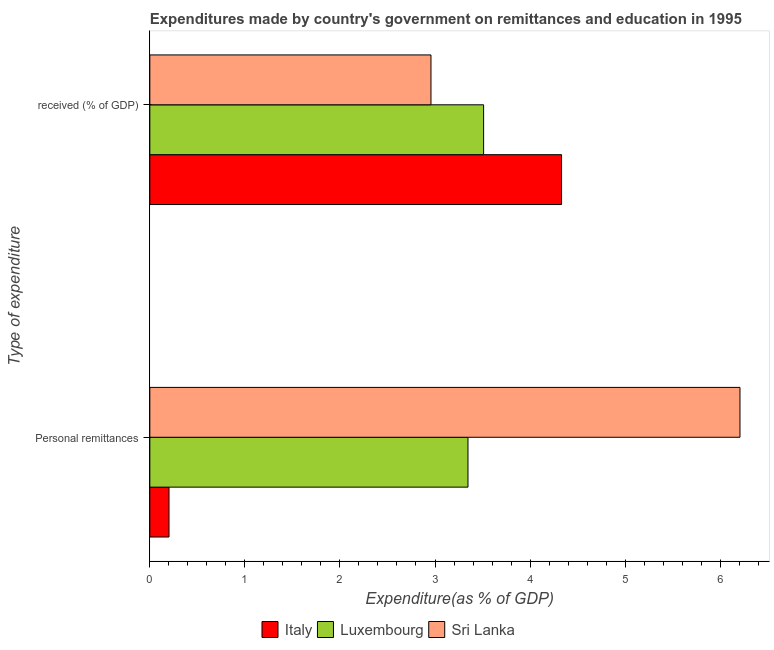How many groups of bars are there?
Keep it short and to the point. 2. Are the number of bars per tick equal to the number of legend labels?
Offer a terse response. Yes. Are the number of bars on each tick of the Y-axis equal?
Ensure brevity in your answer.  Yes. How many bars are there on the 2nd tick from the top?
Provide a short and direct response. 3. What is the label of the 1st group of bars from the top?
Keep it short and to the point.  received (% of GDP). What is the expenditure in education in Sri Lanka?
Make the answer very short. 2.96. Across all countries, what is the maximum expenditure in education?
Your answer should be very brief. 4.33. Across all countries, what is the minimum expenditure in education?
Ensure brevity in your answer.  2.96. In which country was the expenditure in education maximum?
Keep it short and to the point. Italy. In which country was the expenditure in education minimum?
Give a very brief answer. Sri Lanka. What is the total expenditure in personal remittances in the graph?
Give a very brief answer. 9.76. What is the difference between the expenditure in education in Luxembourg and that in Italy?
Provide a short and direct response. -0.82. What is the difference between the expenditure in personal remittances in Luxembourg and the expenditure in education in Italy?
Provide a short and direct response. -0.98. What is the average expenditure in education per country?
Offer a very short reply. 3.6. What is the difference between the expenditure in personal remittances and expenditure in education in Italy?
Make the answer very short. -4.13. In how many countries, is the expenditure in personal remittances greater than 3.4 %?
Keep it short and to the point. 1. What is the ratio of the expenditure in education in Sri Lanka to that in Italy?
Your answer should be very brief. 0.68. Is the expenditure in education in Italy less than that in Sri Lanka?
Keep it short and to the point. No. What does the 3rd bar from the top in  received (% of GDP) represents?
Your answer should be very brief. Italy. What does the 2nd bar from the bottom in Personal remittances represents?
Provide a succinct answer. Luxembourg. How many bars are there?
Ensure brevity in your answer.  6. Are all the bars in the graph horizontal?
Your answer should be compact. Yes. How many countries are there in the graph?
Make the answer very short. 3. What is the difference between two consecutive major ticks on the X-axis?
Your response must be concise. 1. Does the graph contain any zero values?
Give a very brief answer. No. Does the graph contain grids?
Offer a terse response. No. Where does the legend appear in the graph?
Your response must be concise. Bottom center. How are the legend labels stacked?
Ensure brevity in your answer.  Horizontal. What is the title of the graph?
Your response must be concise. Expenditures made by country's government on remittances and education in 1995. Does "Brazil" appear as one of the legend labels in the graph?
Provide a short and direct response. No. What is the label or title of the X-axis?
Offer a terse response. Expenditure(as % of GDP). What is the label or title of the Y-axis?
Ensure brevity in your answer.  Type of expenditure. What is the Expenditure(as % of GDP) of Italy in Personal remittances?
Provide a succinct answer. 0.2. What is the Expenditure(as % of GDP) in Luxembourg in Personal remittances?
Keep it short and to the point. 3.35. What is the Expenditure(as % of GDP) of Sri Lanka in Personal remittances?
Provide a succinct answer. 6.21. What is the Expenditure(as % of GDP) in Italy in  received (% of GDP)?
Your answer should be very brief. 4.33. What is the Expenditure(as % of GDP) of Luxembourg in  received (% of GDP)?
Provide a succinct answer. 3.51. What is the Expenditure(as % of GDP) in Sri Lanka in  received (% of GDP)?
Your answer should be very brief. 2.96. Across all Type of expenditure, what is the maximum Expenditure(as % of GDP) of Italy?
Your answer should be compact. 4.33. Across all Type of expenditure, what is the maximum Expenditure(as % of GDP) in Luxembourg?
Your response must be concise. 3.51. Across all Type of expenditure, what is the maximum Expenditure(as % of GDP) in Sri Lanka?
Offer a terse response. 6.21. Across all Type of expenditure, what is the minimum Expenditure(as % of GDP) in Italy?
Make the answer very short. 0.2. Across all Type of expenditure, what is the minimum Expenditure(as % of GDP) of Luxembourg?
Ensure brevity in your answer.  3.35. Across all Type of expenditure, what is the minimum Expenditure(as % of GDP) in Sri Lanka?
Make the answer very short. 2.96. What is the total Expenditure(as % of GDP) of Italy in the graph?
Your response must be concise. 4.53. What is the total Expenditure(as % of GDP) in Luxembourg in the graph?
Keep it short and to the point. 6.86. What is the total Expenditure(as % of GDP) in Sri Lanka in the graph?
Ensure brevity in your answer.  9.17. What is the difference between the Expenditure(as % of GDP) of Italy in Personal remittances and that in  received (% of GDP)?
Give a very brief answer. -4.13. What is the difference between the Expenditure(as % of GDP) in Luxembourg in Personal remittances and that in  received (% of GDP)?
Your answer should be compact. -0.16. What is the difference between the Expenditure(as % of GDP) of Sri Lanka in Personal remittances and that in  received (% of GDP)?
Provide a succinct answer. 3.25. What is the difference between the Expenditure(as % of GDP) of Italy in Personal remittances and the Expenditure(as % of GDP) of Luxembourg in  received (% of GDP)?
Offer a very short reply. -3.31. What is the difference between the Expenditure(as % of GDP) of Italy in Personal remittances and the Expenditure(as % of GDP) of Sri Lanka in  received (% of GDP)?
Your response must be concise. -2.76. What is the difference between the Expenditure(as % of GDP) of Luxembourg in Personal remittances and the Expenditure(as % of GDP) of Sri Lanka in  received (% of GDP)?
Keep it short and to the point. 0.39. What is the average Expenditure(as % of GDP) of Italy per Type of expenditure?
Your answer should be very brief. 2.27. What is the average Expenditure(as % of GDP) of Luxembourg per Type of expenditure?
Provide a short and direct response. 3.43. What is the average Expenditure(as % of GDP) in Sri Lanka per Type of expenditure?
Offer a very short reply. 4.58. What is the difference between the Expenditure(as % of GDP) of Italy and Expenditure(as % of GDP) of Luxembourg in Personal remittances?
Your answer should be very brief. -3.15. What is the difference between the Expenditure(as % of GDP) of Italy and Expenditure(as % of GDP) of Sri Lanka in Personal remittances?
Provide a succinct answer. -6.01. What is the difference between the Expenditure(as % of GDP) of Luxembourg and Expenditure(as % of GDP) of Sri Lanka in Personal remittances?
Your response must be concise. -2.86. What is the difference between the Expenditure(as % of GDP) of Italy and Expenditure(as % of GDP) of Luxembourg in  received (% of GDP)?
Your answer should be compact. 0.82. What is the difference between the Expenditure(as % of GDP) in Italy and Expenditure(as % of GDP) in Sri Lanka in  received (% of GDP)?
Your response must be concise. 1.37. What is the difference between the Expenditure(as % of GDP) in Luxembourg and Expenditure(as % of GDP) in Sri Lanka in  received (% of GDP)?
Your answer should be very brief. 0.55. What is the ratio of the Expenditure(as % of GDP) of Italy in Personal remittances to that in  received (% of GDP)?
Your answer should be compact. 0.05. What is the ratio of the Expenditure(as % of GDP) in Luxembourg in Personal remittances to that in  received (% of GDP)?
Offer a very short reply. 0.95. What is the ratio of the Expenditure(as % of GDP) in Sri Lanka in Personal remittances to that in  received (% of GDP)?
Your response must be concise. 2.1. What is the difference between the highest and the second highest Expenditure(as % of GDP) of Italy?
Provide a short and direct response. 4.13. What is the difference between the highest and the second highest Expenditure(as % of GDP) in Luxembourg?
Your answer should be compact. 0.16. What is the difference between the highest and the second highest Expenditure(as % of GDP) in Sri Lanka?
Give a very brief answer. 3.25. What is the difference between the highest and the lowest Expenditure(as % of GDP) of Italy?
Provide a short and direct response. 4.13. What is the difference between the highest and the lowest Expenditure(as % of GDP) in Luxembourg?
Keep it short and to the point. 0.16. What is the difference between the highest and the lowest Expenditure(as % of GDP) of Sri Lanka?
Keep it short and to the point. 3.25. 